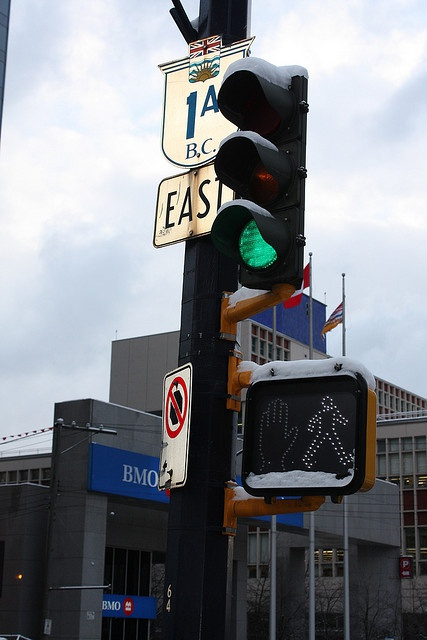Describe the objects in this image and their specific colors. I can see traffic light in gray, black, darkgray, and maroon tones and traffic light in gray, black, green, and darkgray tones in this image. 